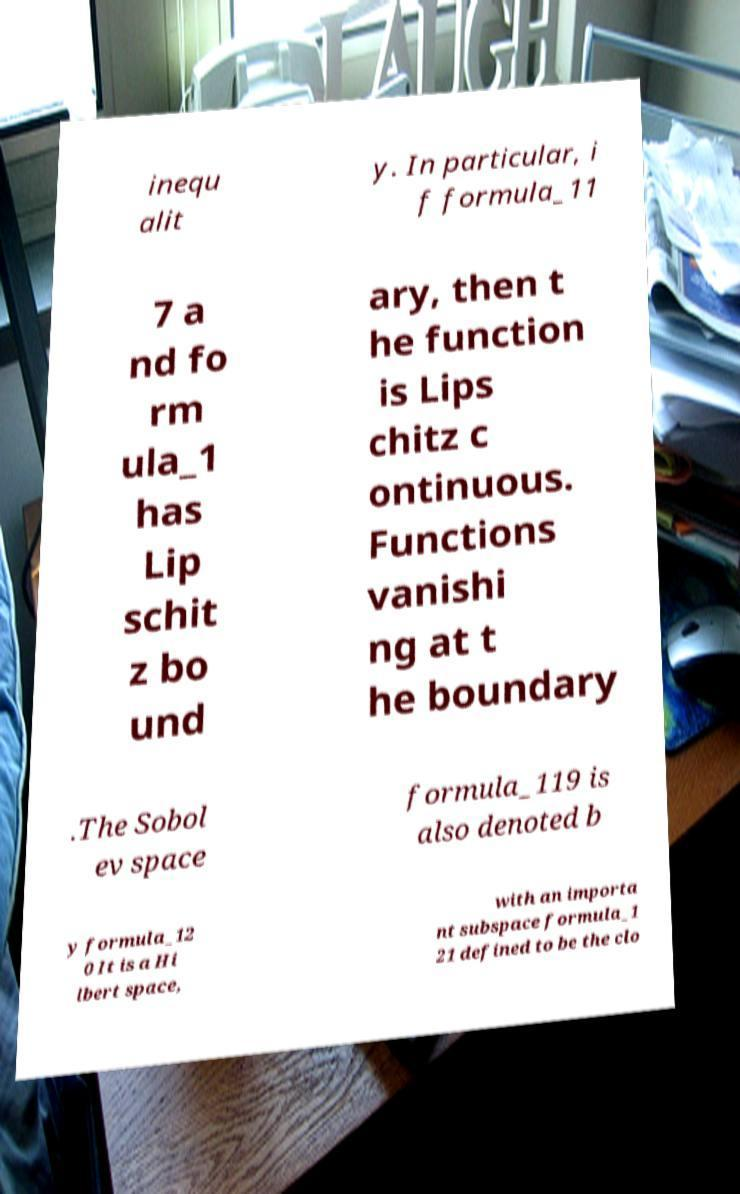Please read and relay the text visible in this image. What does it say? inequ alit y. In particular, i f formula_11 7 a nd fo rm ula_1 has Lip schit z bo und ary, then t he function is Lips chitz c ontinuous. Functions vanishi ng at t he boundary .The Sobol ev space formula_119 is also denoted b y formula_12 0 It is a Hi lbert space, with an importa nt subspace formula_1 21 defined to be the clo 